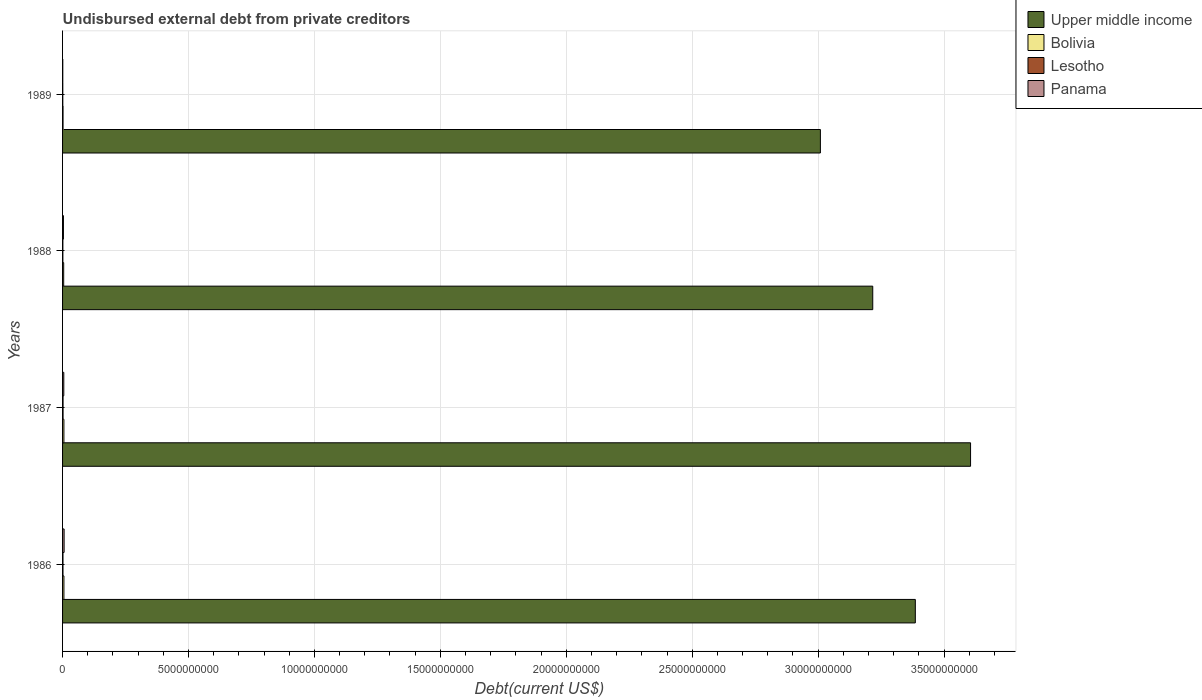How many groups of bars are there?
Make the answer very short. 4. How many bars are there on the 2nd tick from the top?
Your response must be concise. 4. In how many cases, is the number of bars for a given year not equal to the number of legend labels?
Make the answer very short. 0. What is the total debt in Lesotho in 1989?
Provide a short and direct response. 9.38e+06. Across all years, what is the maximum total debt in Panama?
Your answer should be compact. 6.15e+07. Across all years, what is the minimum total debt in Panama?
Offer a terse response. 8.26e+06. In which year was the total debt in Bolivia maximum?
Offer a very short reply. 1986. What is the total total debt in Upper middle income in the graph?
Provide a short and direct response. 1.32e+11. What is the difference between the total debt in Upper middle income in 1987 and that in 1988?
Offer a terse response. 3.88e+09. What is the difference between the total debt in Upper middle income in 1989 and the total debt in Panama in 1986?
Provide a succinct answer. 3.00e+1. What is the average total debt in Bolivia per year?
Offer a very short reply. 4.26e+07. In the year 1989, what is the difference between the total debt in Bolivia and total debt in Panama?
Keep it short and to the point. 1.07e+07. What is the ratio of the total debt in Upper middle income in 1987 to that in 1989?
Offer a very short reply. 1.2. Is the total debt in Lesotho in 1987 less than that in 1989?
Provide a succinct answer. No. Is the difference between the total debt in Bolivia in 1986 and 1988 greater than the difference between the total debt in Panama in 1986 and 1988?
Your answer should be compact. No. What is the difference between the highest and the second highest total debt in Bolivia?
Make the answer very short. 8.19e+05. What is the difference between the highest and the lowest total debt in Bolivia?
Provide a short and direct response. 3.49e+07. Is it the case that in every year, the sum of the total debt in Lesotho and total debt in Bolivia is greater than the sum of total debt in Panama and total debt in Upper middle income?
Give a very brief answer. No. What does the 1st bar from the top in 1986 represents?
Make the answer very short. Panama. What does the 1st bar from the bottom in 1987 represents?
Offer a terse response. Upper middle income. How many years are there in the graph?
Ensure brevity in your answer.  4. Does the graph contain any zero values?
Provide a succinct answer. No. Does the graph contain grids?
Your answer should be compact. Yes. Where does the legend appear in the graph?
Make the answer very short. Top right. What is the title of the graph?
Ensure brevity in your answer.  Undisbursed external debt from private creditors. Does "Trinidad and Tobago" appear as one of the legend labels in the graph?
Your answer should be compact. No. What is the label or title of the X-axis?
Offer a terse response. Debt(current US$). What is the Debt(current US$) of Upper middle income in 1986?
Your answer should be compact. 3.39e+1. What is the Debt(current US$) of Bolivia in 1986?
Keep it short and to the point. 5.38e+07. What is the Debt(current US$) in Lesotho in 1986?
Keep it short and to the point. 1.64e+07. What is the Debt(current US$) of Panama in 1986?
Provide a succinct answer. 6.15e+07. What is the Debt(current US$) of Upper middle income in 1987?
Your answer should be very brief. 3.61e+1. What is the Debt(current US$) of Bolivia in 1987?
Provide a short and direct response. 5.30e+07. What is the Debt(current US$) in Lesotho in 1987?
Your answer should be compact. 2.00e+07. What is the Debt(current US$) of Panama in 1987?
Give a very brief answer. 4.87e+07. What is the Debt(current US$) of Upper middle income in 1988?
Your answer should be very brief. 3.22e+1. What is the Debt(current US$) of Bolivia in 1988?
Your answer should be compact. 4.45e+07. What is the Debt(current US$) in Lesotho in 1988?
Provide a short and direct response. 1.20e+07. What is the Debt(current US$) of Panama in 1988?
Offer a very short reply. 3.45e+07. What is the Debt(current US$) in Upper middle income in 1989?
Your answer should be compact. 3.01e+1. What is the Debt(current US$) in Bolivia in 1989?
Give a very brief answer. 1.89e+07. What is the Debt(current US$) in Lesotho in 1989?
Provide a succinct answer. 9.38e+06. What is the Debt(current US$) in Panama in 1989?
Provide a short and direct response. 8.26e+06. Across all years, what is the maximum Debt(current US$) in Upper middle income?
Your answer should be very brief. 3.61e+1. Across all years, what is the maximum Debt(current US$) of Bolivia?
Make the answer very short. 5.38e+07. Across all years, what is the maximum Debt(current US$) in Lesotho?
Provide a succinct answer. 2.00e+07. Across all years, what is the maximum Debt(current US$) of Panama?
Provide a succinct answer. 6.15e+07. Across all years, what is the minimum Debt(current US$) in Upper middle income?
Make the answer very short. 3.01e+1. Across all years, what is the minimum Debt(current US$) in Bolivia?
Ensure brevity in your answer.  1.89e+07. Across all years, what is the minimum Debt(current US$) of Lesotho?
Ensure brevity in your answer.  9.38e+06. Across all years, what is the minimum Debt(current US$) of Panama?
Offer a very short reply. 8.26e+06. What is the total Debt(current US$) in Upper middle income in the graph?
Your answer should be compact. 1.32e+11. What is the total Debt(current US$) of Bolivia in the graph?
Offer a very short reply. 1.70e+08. What is the total Debt(current US$) of Lesotho in the graph?
Your answer should be very brief. 5.77e+07. What is the total Debt(current US$) in Panama in the graph?
Make the answer very short. 1.53e+08. What is the difference between the Debt(current US$) in Upper middle income in 1986 and that in 1987?
Keep it short and to the point. -2.19e+09. What is the difference between the Debt(current US$) of Bolivia in 1986 and that in 1987?
Give a very brief answer. 8.19e+05. What is the difference between the Debt(current US$) in Lesotho in 1986 and that in 1987?
Your answer should be very brief. -3.58e+06. What is the difference between the Debt(current US$) in Panama in 1986 and that in 1987?
Your response must be concise. 1.28e+07. What is the difference between the Debt(current US$) of Upper middle income in 1986 and that in 1988?
Make the answer very short. 1.69e+09. What is the difference between the Debt(current US$) in Bolivia in 1986 and that in 1988?
Provide a short and direct response. 9.30e+06. What is the difference between the Debt(current US$) of Lesotho in 1986 and that in 1988?
Offer a terse response. 4.42e+06. What is the difference between the Debt(current US$) in Panama in 1986 and that in 1988?
Offer a terse response. 2.70e+07. What is the difference between the Debt(current US$) of Upper middle income in 1986 and that in 1989?
Your response must be concise. 3.77e+09. What is the difference between the Debt(current US$) of Bolivia in 1986 and that in 1989?
Provide a short and direct response. 3.49e+07. What is the difference between the Debt(current US$) of Lesotho in 1986 and that in 1989?
Ensure brevity in your answer.  7.01e+06. What is the difference between the Debt(current US$) of Panama in 1986 and that in 1989?
Make the answer very short. 5.33e+07. What is the difference between the Debt(current US$) of Upper middle income in 1987 and that in 1988?
Give a very brief answer. 3.88e+09. What is the difference between the Debt(current US$) in Bolivia in 1987 and that in 1988?
Ensure brevity in your answer.  8.48e+06. What is the difference between the Debt(current US$) in Lesotho in 1987 and that in 1988?
Make the answer very short. 7.99e+06. What is the difference between the Debt(current US$) of Panama in 1987 and that in 1988?
Give a very brief answer. 1.42e+07. What is the difference between the Debt(current US$) in Upper middle income in 1987 and that in 1989?
Provide a succinct answer. 5.96e+09. What is the difference between the Debt(current US$) in Bolivia in 1987 and that in 1989?
Keep it short and to the point. 3.40e+07. What is the difference between the Debt(current US$) of Lesotho in 1987 and that in 1989?
Provide a succinct answer. 1.06e+07. What is the difference between the Debt(current US$) of Panama in 1987 and that in 1989?
Make the answer very short. 4.04e+07. What is the difference between the Debt(current US$) of Upper middle income in 1988 and that in 1989?
Offer a terse response. 2.08e+09. What is the difference between the Debt(current US$) of Bolivia in 1988 and that in 1989?
Provide a succinct answer. 2.56e+07. What is the difference between the Debt(current US$) in Lesotho in 1988 and that in 1989?
Provide a succinct answer. 2.59e+06. What is the difference between the Debt(current US$) in Panama in 1988 and that in 1989?
Keep it short and to the point. 2.62e+07. What is the difference between the Debt(current US$) in Upper middle income in 1986 and the Debt(current US$) in Bolivia in 1987?
Offer a very short reply. 3.38e+1. What is the difference between the Debt(current US$) of Upper middle income in 1986 and the Debt(current US$) of Lesotho in 1987?
Give a very brief answer. 3.38e+1. What is the difference between the Debt(current US$) in Upper middle income in 1986 and the Debt(current US$) in Panama in 1987?
Your response must be concise. 3.38e+1. What is the difference between the Debt(current US$) in Bolivia in 1986 and the Debt(current US$) in Lesotho in 1987?
Your answer should be very brief. 3.38e+07. What is the difference between the Debt(current US$) in Bolivia in 1986 and the Debt(current US$) in Panama in 1987?
Make the answer very short. 5.12e+06. What is the difference between the Debt(current US$) in Lesotho in 1986 and the Debt(current US$) in Panama in 1987?
Keep it short and to the point. -3.23e+07. What is the difference between the Debt(current US$) in Upper middle income in 1986 and the Debt(current US$) in Bolivia in 1988?
Offer a very short reply. 3.38e+1. What is the difference between the Debt(current US$) in Upper middle income in 1986 and the Debt(current US$) in Lesotho in 1988?
Make the answer very short. 3.38e+1. What is the difference between the Debt(current US$) of Upper middle income in 1986 and the Debt(current US$) of Panama in 1988?
Your response must be concise. 3.38e+1. What is the difference between the Debt(current US$) in Bolivia in 1986 and the Debt(current US$) in Lesotho in 1988?
Provide a short and direct response. 4.18e+07. What is the difference between the Debt(current US$) in Bolivia in 1986 and the Debt(current US$) in Panama in 1988?
Offer a terse response. 1.93e+07. What is the difference between the Debt(current US$) in Lesotho in 1986 and the Debt(current US$) in Panama in 1988?
Keep it short and to the point. -1.81e+07. What is the difference between the Debt(current US$) of Upper middle income in 1986 and the Debt(current US$) of Bolivia in 1989?
Your response must be concise. 3.38e+1. What is the difference between the Debt(current US$) of Upper middle income in 1986 and the Debt(current US$) of Lesotho in 1989?
Your answer should be very brief. 3.39e+1. What is the difference between the Debt(current US$) in Upper middle income in 1986 and the Debt(current US$) in Panama in 1989?
Keep it short and to the point. 3.39e+1. What is the difference between the Debt(current US$) of Bolivia in 1986 and the Debt(current US$) of Lesotho in 1989?
Your response must be concise. 4.44e+07. What is the difference between the Debt(current US$) of Bolivia in 1986 and the Debt(current US$) of Panama in 1989?
Ensure brevity in your answer.  4.55e+07. What is the difference between the Debt(current US$) in Lesotho in 1986 and the Debt(current US$) in Panama in 1989?
Give a very brief answer. 8.12e+06. What is the difference between the Debt(current US$) of Upper middle income in 1987 and the Debt(current US$) of Bolivia in 1988?
Provide a succinct answer. 3.60e+1. What is the difference between the Debt(current US$) of Upper middle income in 1987 and the Debt(current US$) of Lesotho in 1988?
Your response must be concise. 3.60e+1. What is the difference between the Debt(current US$) of Upper middle income in 1987 and the Debt(current US$) of Panama in 1988?
Offer a very short reply. 3.60e+1. What is the difference between the Debt(current US$) in Bolivia in 1987 and the Debt(current US$) in Lesotho in 1988?
Provide a short and direct response. 4.10e+07. What is the difference between the Debt(current US$) in Bolivia in 1987 and the Debt(current US$) in Panama in 1988?
Offer a very short reply. 1.85e+07. What is the difference between the Debt(current US$) in Lesotho in 1987 and the Debt(current US$) in Panama in 1988?
Your response must be concise. -1.45e+07. What is the difference between the Debt(current US$) of Upper middle income in 1987 and the Debt(current US$) of Bolivia in 1989?
Your answer should be very brief. 3.60e+1. What is the difference between the Debt(current US$) in Upper middle income in 1987 and the Debt(current US$) in Lesotho in 1989?
Offer a very short reply. 3.60e+1. What is the difference between the Debt(current US$) in Upper middle income in 1987 and the Debt(current US$) in Panama in 1989?
Offer a very short reply. 3.60e+1. What is the difference between the Debt(current US$) of Bolivia in 1987 and the Debt(current US$) of Lesotho in 1989?
Your response must be concise. 4.36e+07. What is the difference between the Debt(current US$) of Bolivia in 1987 and the Debt(current US$) of Panama in 1989?
Your answer should be very brief. 4.47e+07. What is the difference between the Debt(current US$) of Lesotho in 1987 and the Debt(current US$) of Panama in 1989?
Offer a very short reply. 1.17e+07. What is the difference between the Debt(current US$) in Upper middle income in 1988 and the Debt(current US$) in Bolivia in 1989?
Offer a terse response. 3.22e+1. What is the difference between the Debt(current US$) in Upper middle income in 1988 and the Debt(current US$) in Lesotho in 1989?
Keep it short and to the point. 3.22e+1. What is the difference between the Debt(current US$) of Upper middle income in 1988 and the Debt(current US$) of Panama in 1989?
Offer a terse response. 3.22e+1. What is the difference between the Debt(current US$) of Bolivia in 1988 and the Debt(current US$) of Lesotho in 1989?
Offer a very short reply. 3.51e+07. What is the difference between the Debt(current US$) of Bolivia in 1988 and the Debt(current US$) of Panama in 1989?
Keep it short and to the point. 3.62e+07. What is the difference between the Debt(current US$) in Lesotho in 1988 and the Debt(current US$) in Panama in 1989?
Make the answer very short. 3.70e+06. What is the average Debt(current US$) in Upper middle income per year?
Offer a terse response. 3.30e+1. What is the average Debt(current US$) in Bolivia per year?
Keep it short and to the point. 4.26e+07. What is the average Debt(current US$) in Lesotho per year?
Your response must be concise. 1.44e+07. What is the average Debt(current US$) of Panama per year?
Your answer should be compact. 3.82e+07. In the year 1986, what is the difference between the Debt(current US$) of Upper middle income and Debt(current US$) of Bolivia?
Ensure brevity in your answer.  3.38e+1. In the year 1986, what is the difference between the Debt(current US$) of Upper middle income and Debt(current US$) of Lesotho?
Your answer should be compact. 3.38e+1. In the year 1986, what is the difference between the Debt(current US$) of Upper middle income and Debt(current US$) of Panama?
Offer a very short reply. 3.38e+1. In the year 1986, what is the difference between the Debt(current US$) in Bolivia and Debt(current US$) in Lesotho?
Provide a succinct answer. 3.74e+07. In the year 1986, what is the difference between the Debt(current US$) in Bolivia and Debt(current US$) in Panama?
Give a very brief answer. -7.72e+06. In the year 1986, what is the difference between the Debt(current US$) in Lesotho and Debt(current US$) in Panama?
Provide a succinct answer. -4.51e+07. In the year 1987, what is the difference between the Debt(current US$) in Upper middle income and Debt(current US$) in Bolivia?
Your response must be concise. 3.60e+1. In the year 1987, what is the difference between the Debt(current US$) of Upper middle income and Debt(current US$) of Lesotho?
Make the answer very short. 3.60e+1. In the year 1987, what is the difference between the Debt(current US$) of Upper middle income and Debt(current US$) of Panama?
Your answer should be compact. 3.60e+1. In the year 1987, what is the difference between the Debt(current US$) of Bolivia and Debt(current US$) of Lesotho?
Provide a short and direct response. 3.30e+07. In the year 1987, what is the difference between the Debt(current US$) of Bolivia and Debt(current US$) of Panama?
Provide a short and direct response. 4.30e+06. In the year 1987, what is the difference between the Debt(current US$) in Lesotho and Debt(current US$) in Panama?
Provide a short and direct response. -2.87e+07. In the year 1988, what is the difference between the Debt(current US$) in Upper middle income and Debt(current US$) in Bolivia?
Provide a short and direct response. 3.21e+1. In the year 1988, what is the difference between the Debt(current US$) in Upper middle income and Debt(current US$) in Lesotho?
Offer a very short reply. 3.22e+1. In the year 1988, what is the difference between the Debt(current US$) of Upper middle income and Debt(current US$) of Panama?
Offer a terse response. 3.21e+1. In the year 1988, what is the difference between the Debt(current US$) in Bolivia and Debt(current US$) in Lesotho?
Your answer should be compact. 3.25e+07. In the year 1988, what is the difference between the Debt(current US$) of Bolivia and Debt(current US$) of Panama?
Ensure brevity in your answer.  9.99e+06. In the year 1988, what is the difference between the Debt(current US$) in Lesotho and Debt(current US$) in Panama?
Make the answer very short. -2.25e+07. In the year 1989, what is the difference between the Debt(current US$) of Upper middle income and Debt(current US$) of Bolivia?
Offer a very short reply. 3.01e+1. In the year 1989, what is the difference between the Debt(current US$) of Upper middle income and Debt(current US$) of Lesotho?
Offer a terse response. 3.01e+1. In the year 1989, what is the difference between the Debt(current US$) of Upper middle income and Debt(current US$) of Panama?
Provide a succinct answer. 3.01e+1. In the year 1989, what is the difference between the Debt(current US$) of Bolivia and Debt(current US$) of Lesotho?
Make the answer very short. 9.56e+06. In the year 1989, what is the difference between the Debt(current US$) of Bolivia and Debt(current US$) of Panama?
Keep it short and to the point. 1.07e+07. In the year 1989, what is the difference between the Debt(current US$) in Lesotho and Debt(current US$) in Panama?
Provide a succinct answer. 1.11e+06. What is the ratio of the Debt(current US$) in Upper middle income in 1986 to that in 1987?
Offer a terse response. 0.94. What is the ratio of the Debt(current US$) of Bolivia in 1986 to that in 1987?
Your response must be concise. 1.02. What is the ratio of the Debt(current US$) of Lesotho in 1986 to that in 1987?
Ensure brevity in your answer.  0.82. What is the ratio of the Debt(current US$) in Panama in 1986 to that in 1987?
Provide a short and direct response. 1.26. What is the ratio of the Debt(current US$) of Upper middle income in 1986 to that in 1988?
Offer a terse response. 1.05. What is the ratio of the Debt(current US$) of Bolivia in 1986 to that in 1988?
Offer a very short reply. 1.21. What is the ratio of the Debt(current US$) of Lesotho in 1986 to that in 1988?
Your answer should be compact. 1.37. What is the ratio of the Debt(current US$) of Panama in 1986 to that in 1988?
Your response must be concise. 1.78. What is the ratio of the Debt(current US$) of Upper middle income in 1986 to that in 1989?
Keep it short and to the point. 1.13. What is the ratio of the Debt(current US$) in Bolivia in 1986 to that in 1989?
Offer a terse response. 2.84. What is the ratio of the Debt(current US$) of Lesotho in 1986 to that in 1989?
Your answer should be very brief. 1.75. What is the ratio of the Debt(current US$) in Panama in 1986 to that in 1989?
Offer a very short reply. 7.44. What is the ratio of the Debt(current US$) in Upper middle income in 1987 to that in 1988?
Ensure brevity in your answer.  1.12. What is the ratio of the Debt(current US$) in Bolivia in 1987 to that in 1988?
Ensure brevity in your answer.  1.19. What is the ratio of the Debt(current US$) in Lesotho in 1987 to that in 1988?
Offer a very short reply. 1.67. What is the ratio of the Debt(current US$) of Panama in 1987 to that in 1988?
Your answer should be very brief. 1.41. What is the ratio of the Debt(current US$) in Upper middle income in 1987 to that in 1989?
Your answer should be very brief. 1.2. What is the ratio of the Debt(current US$) in Bolivia in 1987 to that in 1989?
Offer a very short reply. 2.8. What is the ratio of the Debt(current US$) in Lesotho in 1987 to that in 1989?
Your answer should be compact. 2.13. What is the ratio of the Debt(current US$) of Panama in 1987 to that in 1989?
Provide a short and direct response. 5.89. What is the ratio of the Debt(current US$) of Upper middle income in 1988 to that in 1989?
Your response must be concise. 1.07. What is the ratio of the Debt(current US$) in Bolivia in 1988 to that in 1989?
Ensure brevity in your answer.  2.35. What is the ratio of the Debt(current US$) of Lesotho in 1988 to that in 1989?
Your answer should be compact. 1.28. What is the ratio of the Debt(current US$) of Panama in 1988 to that in 1989?
Offer a very short reply. 4.17. What is the difference between the highest and the second highest Debt(current US$) in Upper middle income?
Your answer should be very brief. 2.19e+09. What is the difference between the highest and the second highest Debt(current US$) of Bolivia?
Keep it short and to the point. 8.19e+05. What is the difference between the highest and the second highest Debt(current US$) in Lesotho?
Provide a short and direct response. 3.58e+06. What is the difference between the highest and the second highest Debt(current US$) of Panama?
Your answer should be very brief. 1.28e+07. What is the difference between the highest and the lowest Debt(current US$) in Upper middle income?
Provide a short and direct response. 5.96e+09. What is the difference between the highest and the lowest Debt(current US$) of Bolivia?
Your response must be concise. 3.49e+07. What is the difference between the highest and the lowest Debt(current US$) in Lesotho?
Ensure brevity in your answer.  1.06e+07. What is the difference between the highest and the lowest Debt(current US$) in Panama?
Provide a short and direct response. 5.33e+07. 